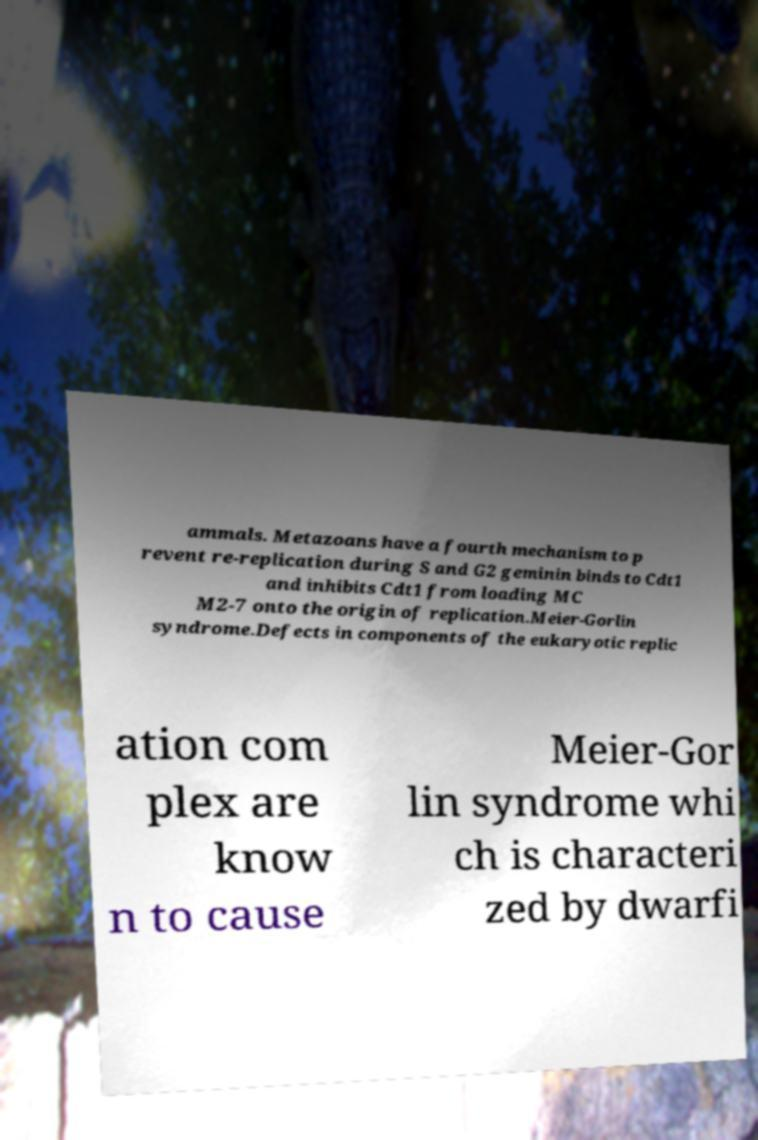What messages or text are displayed in this image? I need them in a readable, typed format. ammals. Metazoans have a fourth mechanism to p revent re-replication during S and G2 geminin binds to Cdt1 and inhibits Cdt1 from loading MC M2-7 onto the origin of replication.Meier-Gorlin syndrome.Defects in components of the eukaryotic replic ation com plex are know n to cause Meier-Gor lin syndrome whi ch is characteri zed by dwarfi 